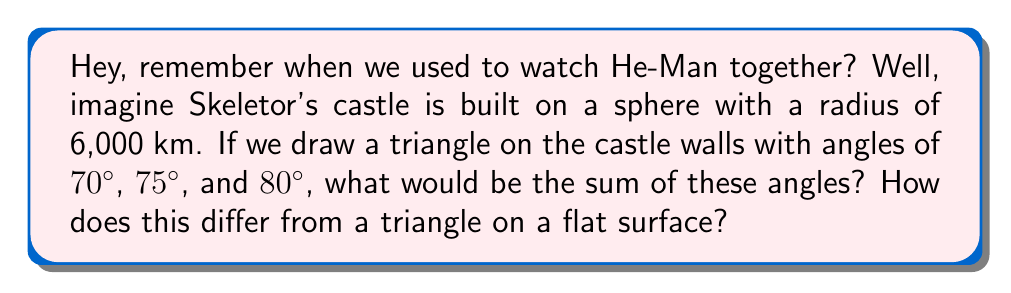Help me with this question. Let's approach this step-by-step:

1) First, recall that on a flat (Euclidean) surface, the sum of angles in a triangle is always 180°.

2) However, Skeletor's castle is on a spherical surface, which is non-Euclidean. On a sphere, the sum of angles in a triangle is always greater than 180°.

3) For a sphere, the sum of angles in a triangle is given by the formula:

   $$\text{Sum of angles} = 180° + \frac{A}{R^2} \cdot \frac{180°}{\pi}$$

   Where $A$ is the area of the triangle and $R$ is the radius of the sphere.

4) We're given the angles of the triangle (70°, 75°, and 80°), but not its area. However, we can calculate the sum directly:

   $$\text{Sum of angles} = 70° + 75° + 80° = 225°$$

5) The excess over 180° (called the spherical excess) is:

   $$\text{Spherical excess} = 225° - 180° = 45°$$

6) This 45° excess is what makes this triangle different from a flat triangle.

7) We can actually use this to calculate the area of the triangle:

   $$45° = \frac{A}{(6000 \text{ km})^2} \cdot \frac{180°}{\pi}$$

   $$A = 45° \cdot \frac{\pi}{180°} \cdot (6000 \text{ km})^2 \approx 14,137,167 \text{ km}^2$$

8) This area is about 2.8% of the total surface area of the sphere, which is quite large!
Answer: 225° 